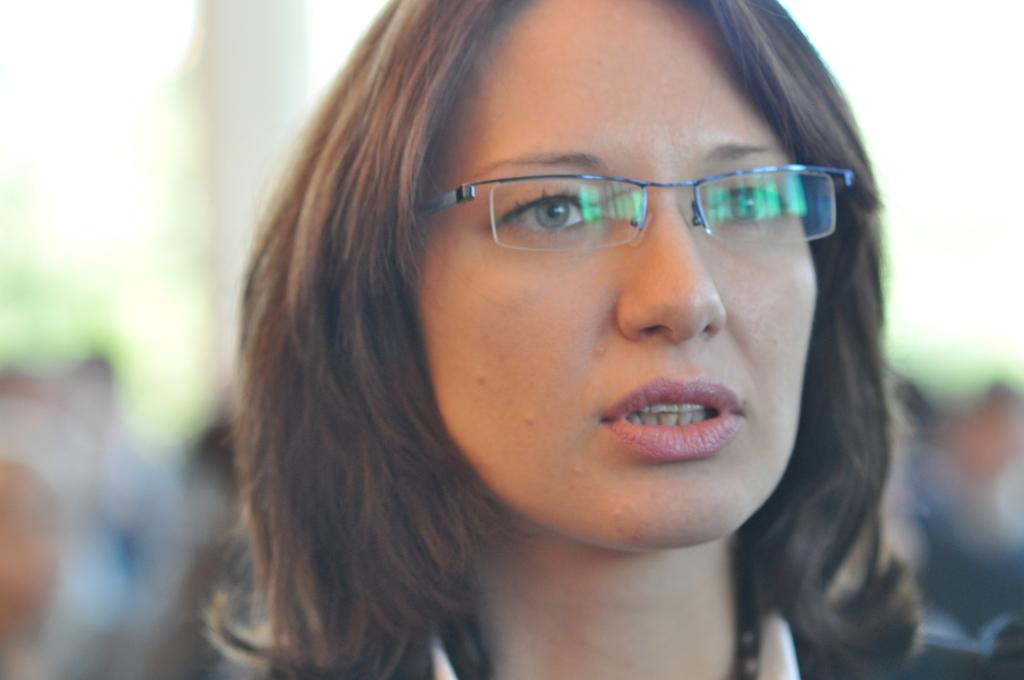Who is the main subject in the picture? There is a woman in the picture. What is the woman wearing that is noticeable? The woman is wearing glasses (specs). What is the woman doing in the picture? The woman is posing for the camera. How would you describe the background of the image? The background of the image is blurred. What type of lamp is hanging above the woman in the image? There is no lamp present in the image; it only features a woman posing for the camera with a blurred background. 